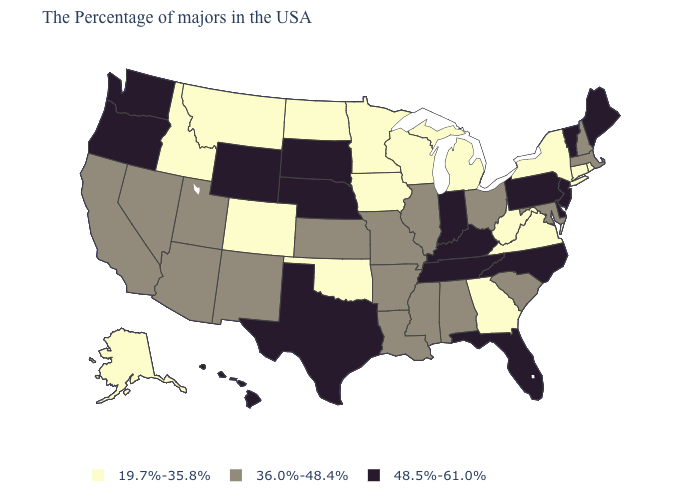Among the states that border Florida , which have the lowest value?
Short answer required. Georgia. What is the value of New Hampshire?
Quick response, please. 36.0%-48.4%. Which states have the lowest value in the USA?
Quick response, please. Rhode Island, Connecticut, New York, Virginia, West Virginia, Georgia, Michigan, Wisconsin, Minnesota, Iowa, Oklahoma, North Dakota, Colorado, Montana, Idaho, Alaska. What is the highest value in the USA?
Keep it brief. 48.5%-61.0%. What is the value of Maine?
Short answer required. 48.5%-61.0%. Does Texas have the lowest value in the USA?
Give a very brief answer. No. What is the value of Illinois?
Short answer required. 36.0%-48.4%. Does Oregon have the highest value in the West?
Short answer required. Yes. How many symbols are there in the legend?
Give a very brief answer. 3. How many symbols are there in the legend?
Be succinct. 3. Name the states that have a value in the range 36.0%-48.4%?
Give a very brief answer. Massachusetts, New Hampshire, Maryland, South Carolina, Ohio, Alabama, Illinois, Mississippi, Louisiana, Missouri, Arkansas, Kansas, New Mexico, Utah, Arizona, Nevada, California. Name the states that have a value in the range 36.0%-48.4%?
Short answer required. Massachusetts, New Hampshire, Maryland, South Carolina, Ohio, Alabama, Illinois, Mississippi, Louisiana, Missouri, Arkansas, Kansas, New Mexico, Utah, Arizona, Nevada, California. Name the states that have a value in the range 36.0%-48.4%?
Be succinct. Massachusetts, New Hampshire, Maryland, South Carolina, Ohio, Alabama, Illinois, Mississippi, Louisiana, Missouri, Arkansas, Kansas, New Mexico, Utah, Arizona, Nevada, California. What is the value of New Hampshire?
Write a very short answer. 36.0%-48.4%. What is the value of Delaware?
Give a very brief answer. 48.5%-61.0%. 